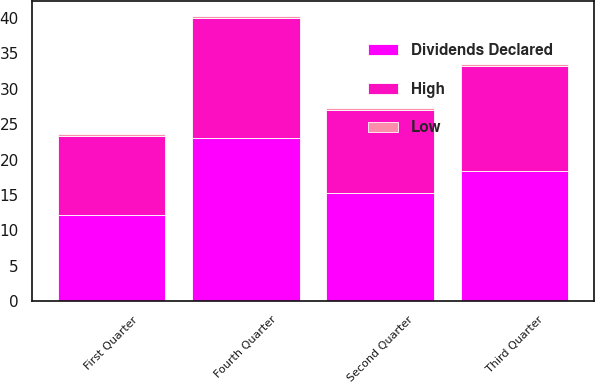Convert chart. <chart><loc_0><loc_0><loc_500><loc_500><stacked_bar_chart><ecel><fcel>First Quarter<fcel>Second Quarter<fcel>Third Quarter<fcel>Fourth Quarter<nl><fcel>Dividends Declared<fcel>12.24<fcel>15.33<fcel>18.33<fcel>22.98<nl><fcel>High<fcel>11.08<fcel>11.67<fcel>14.83<fcel>17.05<nl><fcel>Low<fcel>0.27<fcel>0.27<fcel>0.27<fcel>0.27<nl></chart> 